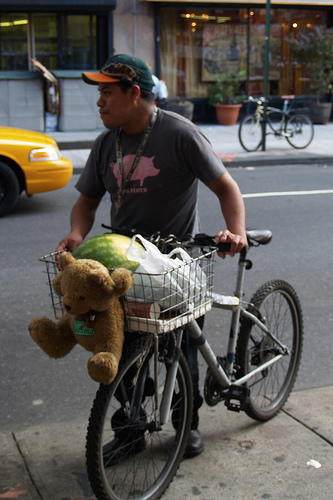<image>
Is there a pole behind the bike? No. The pole is not behind the bike. From this viewpoint, the pole appears to be positioned elsewhere in the scene. 